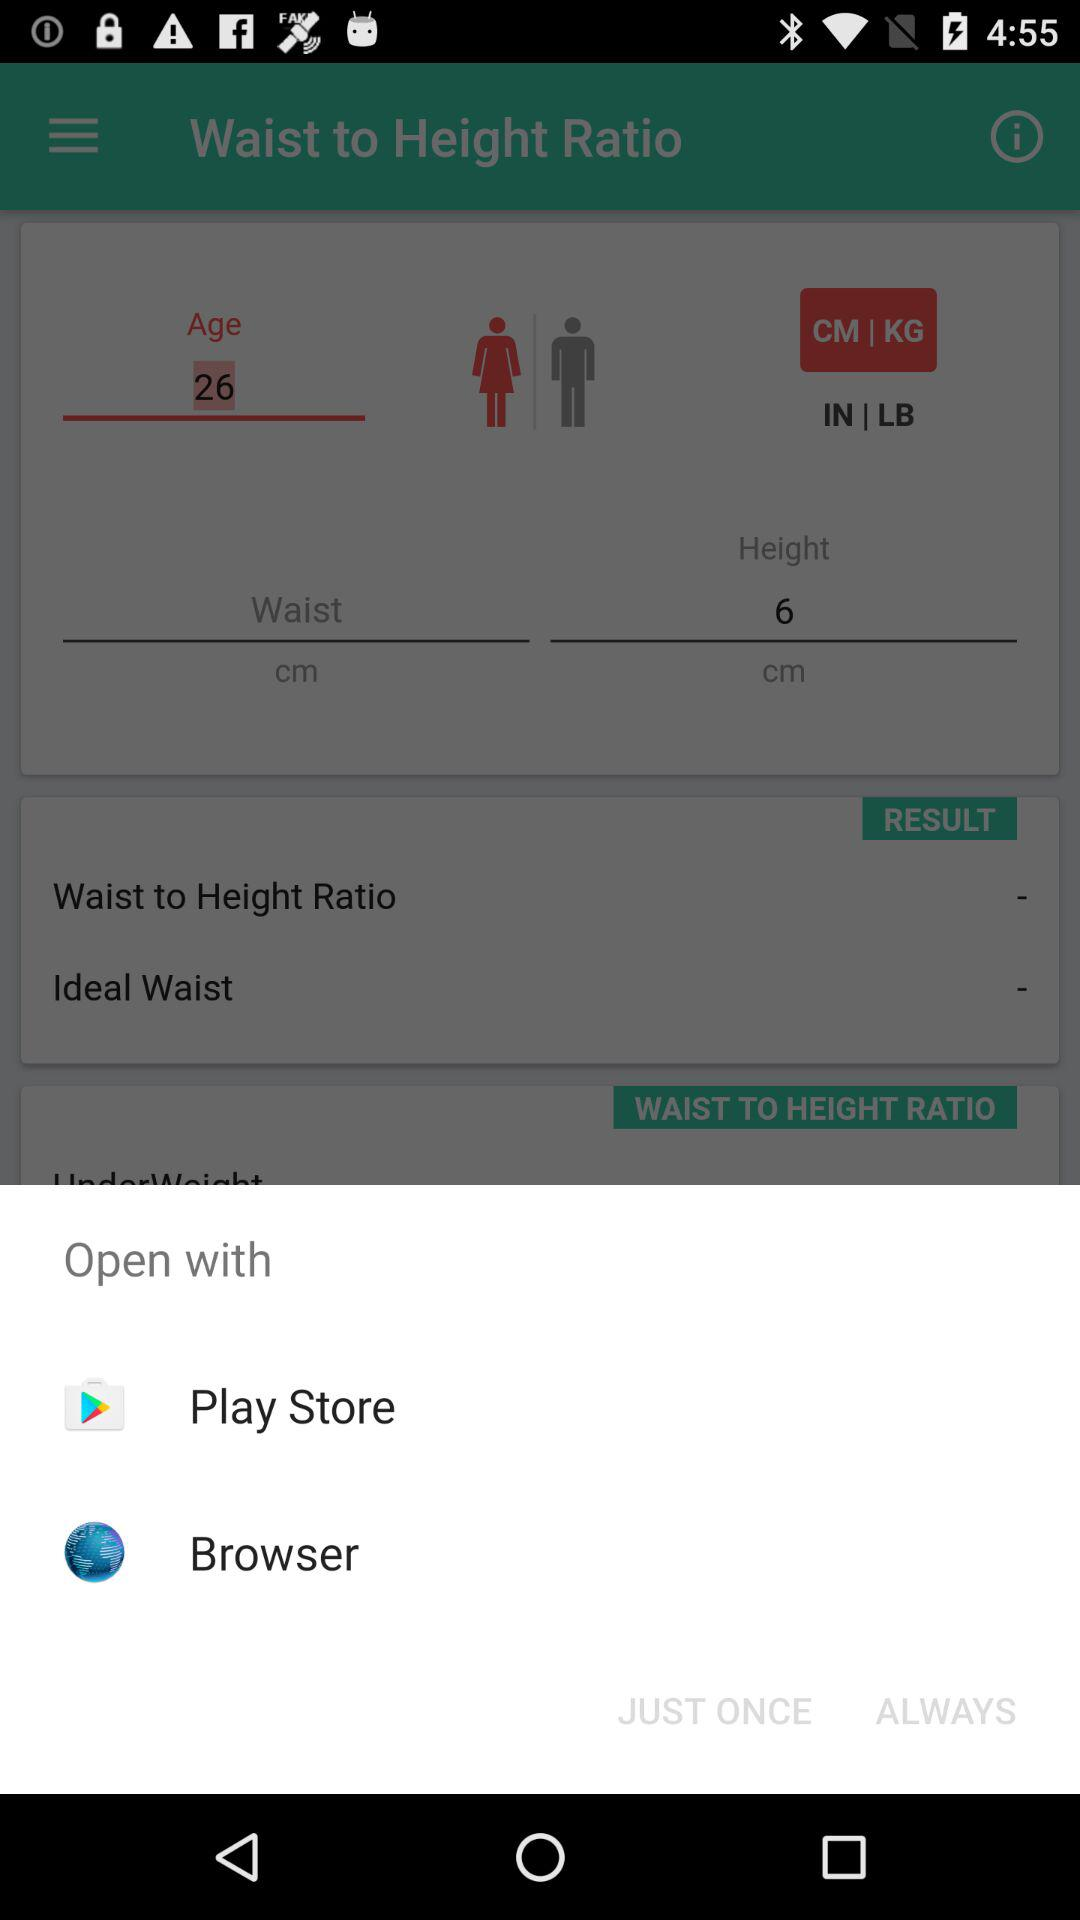Which application can we use to open it? You can use "Play Store" and "Browser" to open it. 